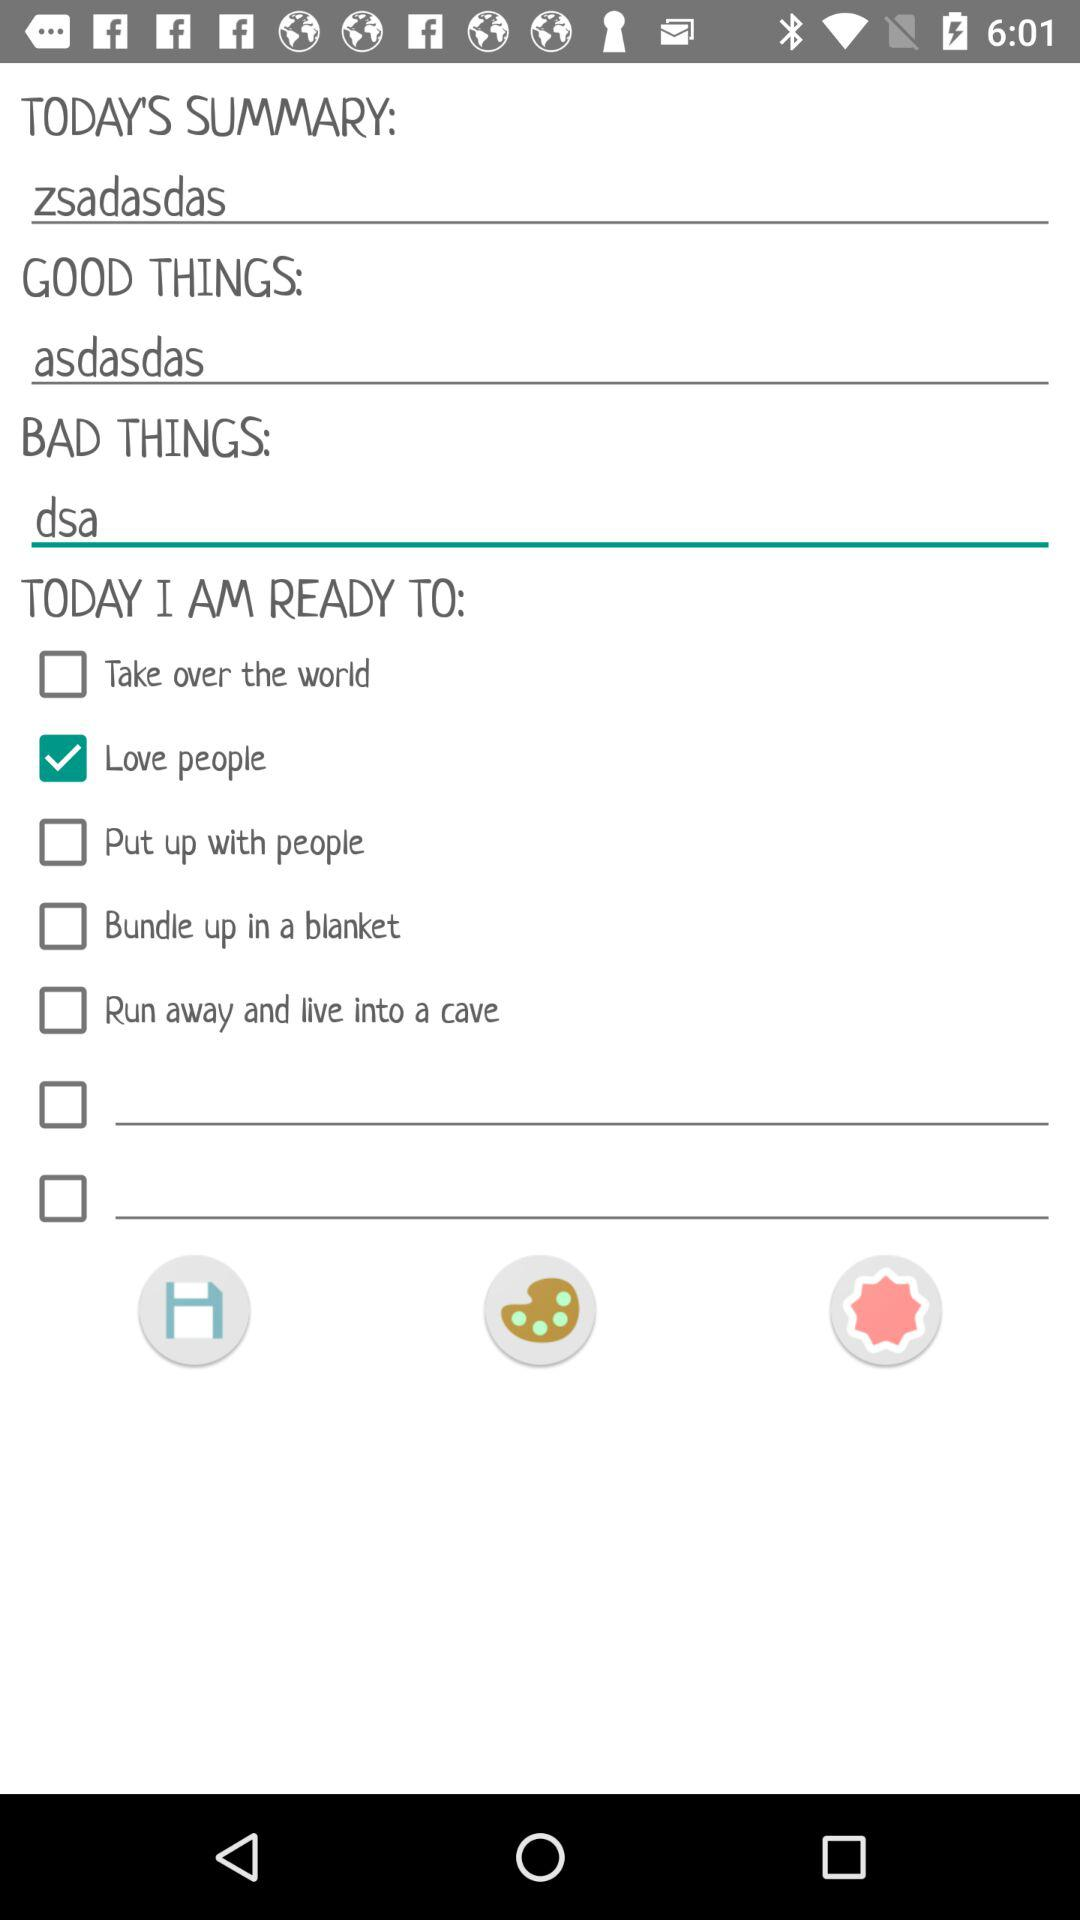What is today's summary? Today's summary is "zsadasdas". 